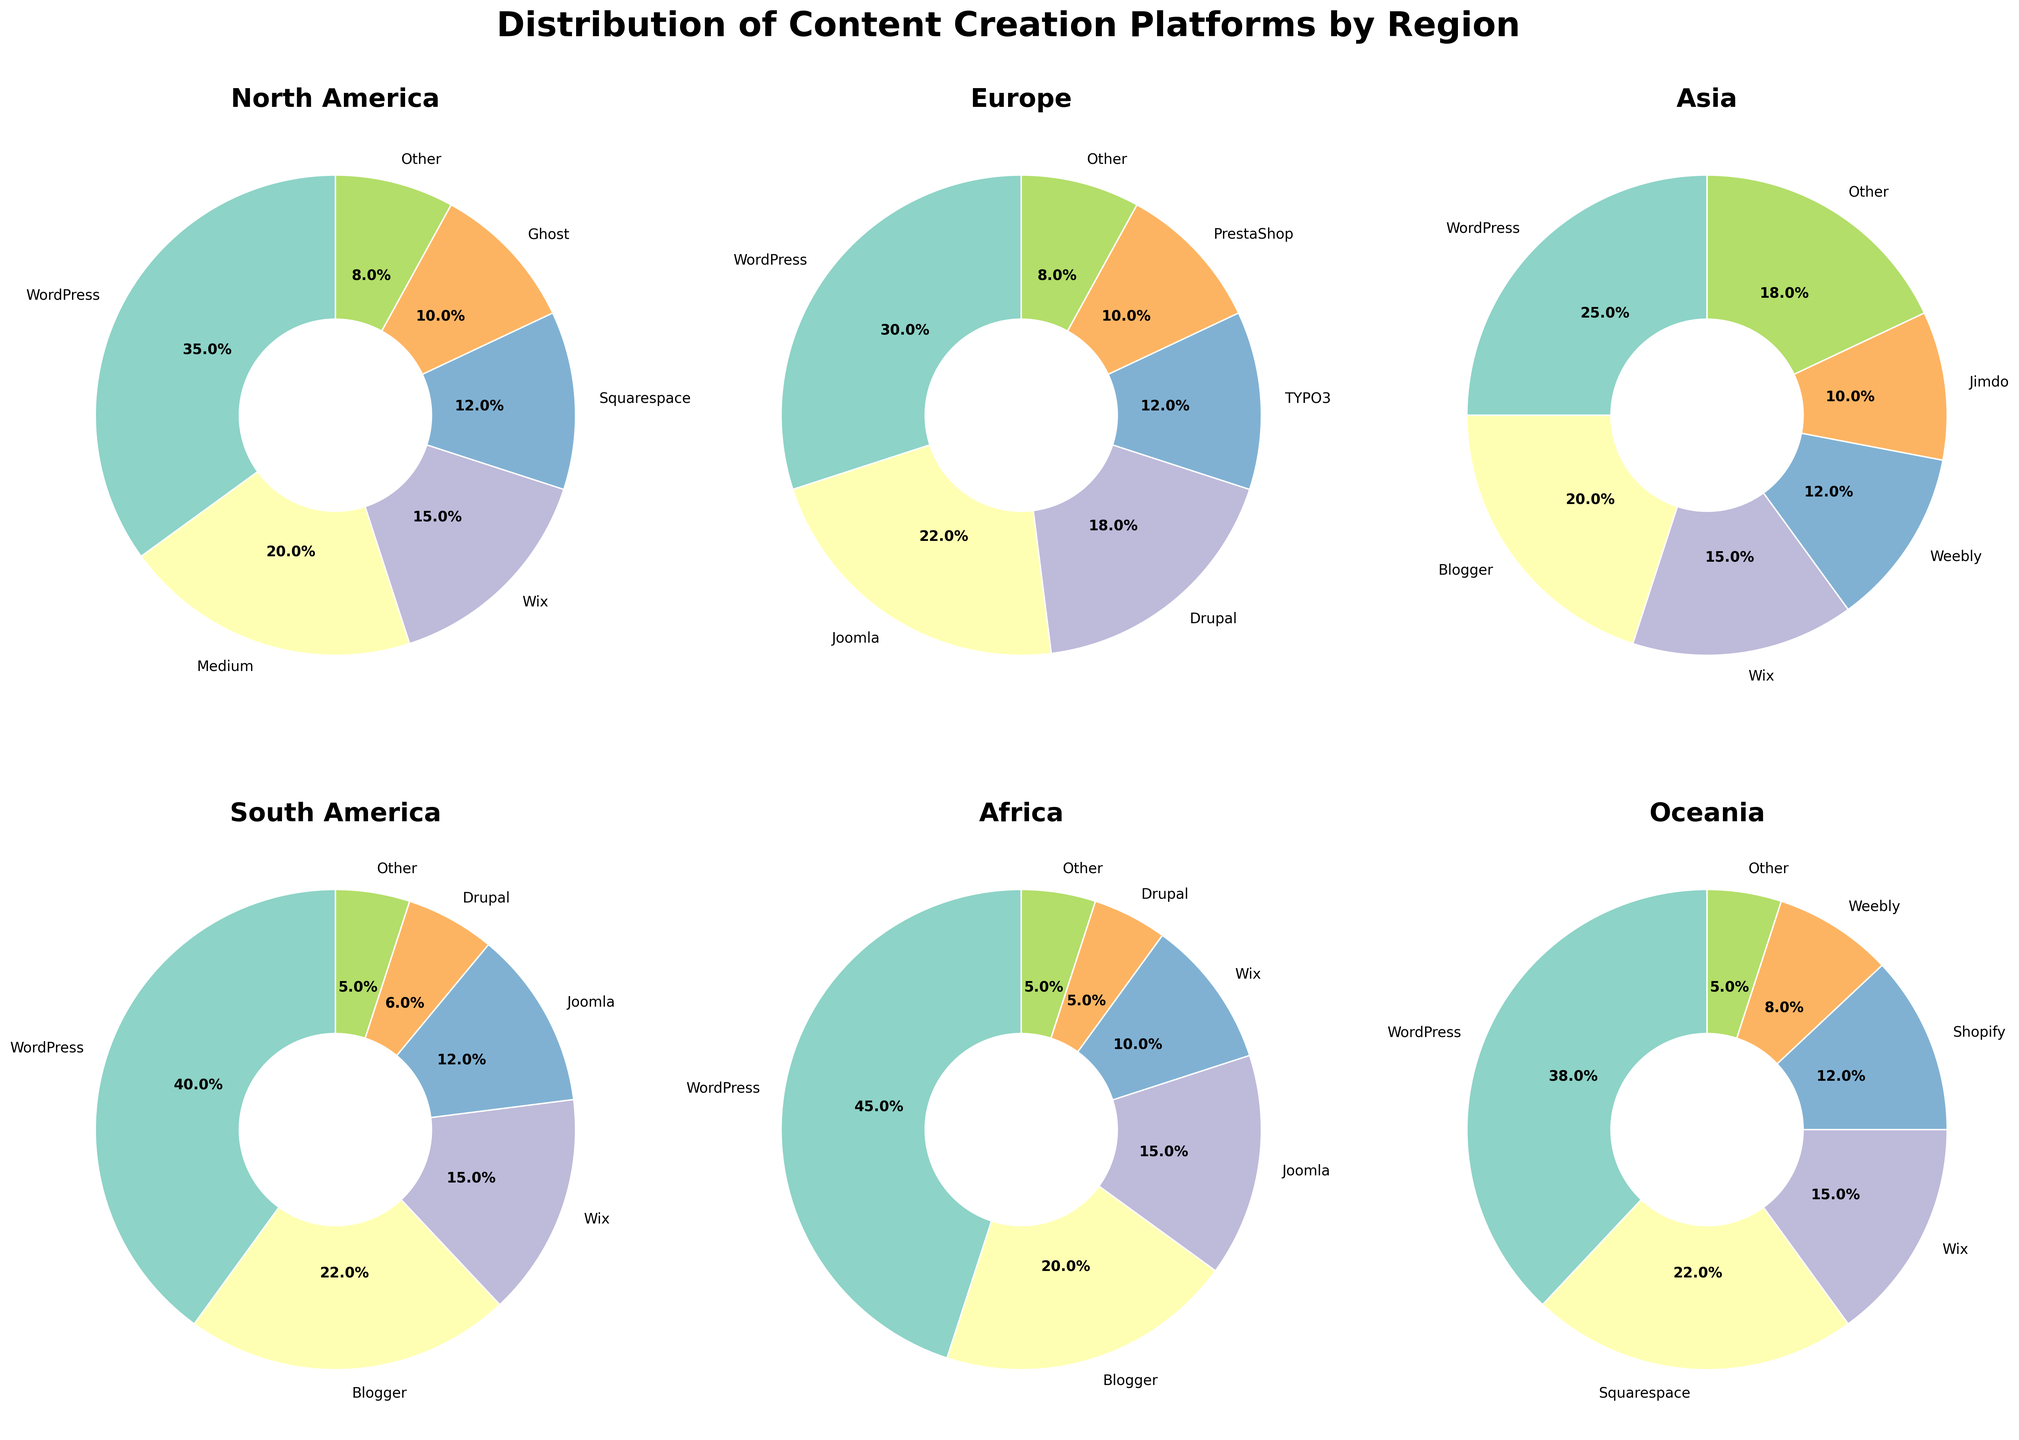Which region has the highest percentage of content creation on WordPress? To determine which region has the highest percentage of content creation on WordPress, we need to look at the slices representing WordPress across all subplots. North America has 35%, Europe has 30%, Asia has 25%, South America has 40%, Africa has 45%, and Oceania has 38%. Therefore, Africa has the highest percentage.
Answer: Africa Which regions have more than 20% of their content created on platforms other than WordPress? To find which regions have more than 20% of their content created on platforms other than WordPress, we need to sum the percentages of all platforms except WordPress for each region. North America: 65%, Europe: 70%, Asia: 75%, South America: 60%, Africa: 55%, and Oceania: 62%. Thus, all regions have more than 20%.
Answer: All regions What is the combined percentage of content creation on Wix for North America and Asia? We need to locate the percentages for Wix in North America and Asia and add them together. North America has 15% and Asia has 15%. So, the combined percentage is 15% + 15% = 30%.
Answer: 30% Which platform is used the least across all regions? Examine the slices corresponding to the smallest percentages across all subplots. "Other" platforms in South America and Africa and "Drupal" in Africa have 5%. These are the lowest individual percentages.
Answer: Other/Drupal Compare the use of Blogger between Asia and Africa, which region uses it more? To compare, we look at the percentages of Blogger in Asia and Africa. Asia uses Blogger at 20% and Africa also uses it at 20%. Thus, the usage is the same.
Answer: Same Is the percentage of content creation on Joomla higher in Europe or South America? Look at the percentages for Joomla in Europe and South America. Europe has 22%, and South America has 12%. Therefore, it is higher in Europe.
Answer: Europe Which region has the most diverse range of content creation platforms? To determine this, count the number of distinct platforms listed and consider substantial percentages. Europe has platforms with 30%, 22%, 18%, 12%, 10%, and 8%. This indicates a high diversity with substantial representation across multiple platforms.
Answer: Europe How much more percentage does WordPress have in South America compared to Europe? Subtract the percentage of WordPress in Europe from that in South America. WordPress in South America is 40%, and in Europe, it's 30%. The difference is 40% - 30% = 10%.
Answer: 10% Which region has the largest "Other" category percentage? Identify the largest "Other" category percentage slice across all regions. Asia's "Other" category is 18%, which is the highest among them all.
Answer: Asia 